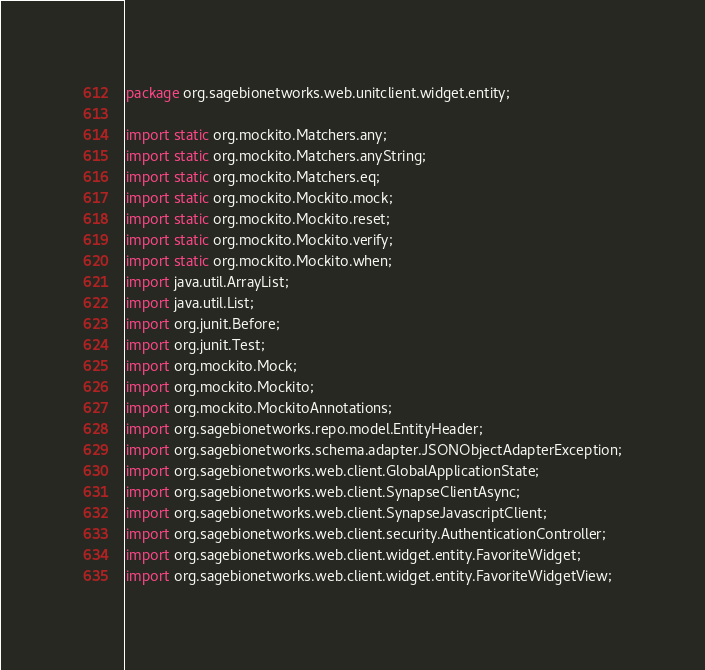<code> <loc_0><loc_0><loc_500><loc_500><_Java_>package org.sagebionetworks.web.unitclient.widget.entity;

import static org.mockito.Matchers.any;
import static org.mockito.Matchers.anyString;
import static org.mockito.Matchers.eq;
import static org.mockito.Mockito.mock;
import static org.mockito.Mockito.reset;
import static org.mockito.Mockito.verify;
import static org.mockito.Mockito.when;
import java.util.ArrayList;
import java.util.List;
import org.junit.Before;
import org.junit.Test;
import org.mockito.Mock;
import org.mockito.Mockito;
import org.mockito.MockitoAnnotations;
import org.sagebionetworks.repo.model.EntityHeader;
import org.sagebionetworks.schema.adapter.JSONObjectAdapterException;
import org.sagebionetworks.web.client.GlobalApplicationState;
import org.sagebionetworks.web.client.SynapseClientAsync;
import org.sagebionetworks.web.client.SynapseJavascriptClient;
import org.sagebionetworks.web.client.security.AuthenticationController;
import org.sagebionetworks.web.client.widget.entity.FavoriteWidget;
import org.sagebionetworks.web.client.widget.entity.FavoriteWidgetView;</code> 